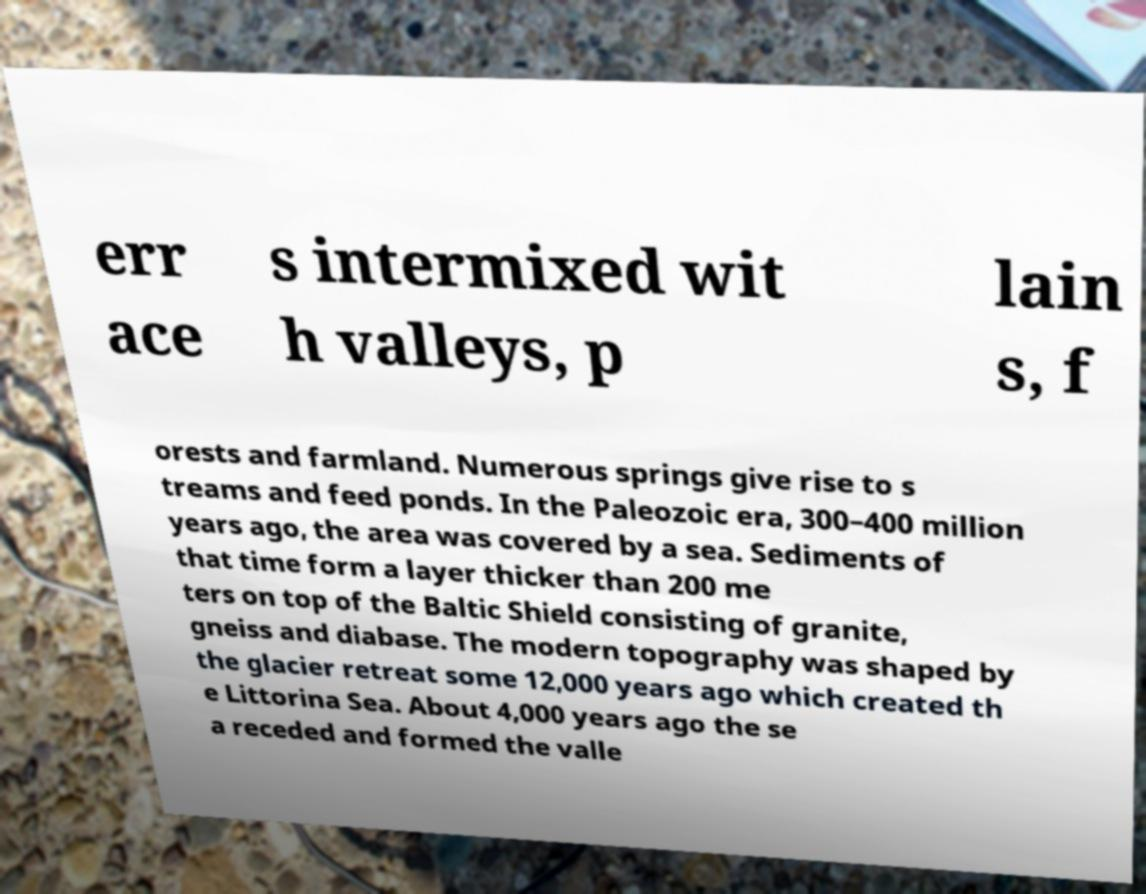Can you accurately transcribe the text from the provided image for me? err ace s intermixed wit h valleys, p lain s, f orests and farmland. Numerous springs give rise to s treams and feed ponds. In the Paleozoic era, 300–400 million years ago, the area was covered by a sea. Sediments of that time form a layer thicker than 200 me ters on top of the Baltic Shield consisting of granite, gneiss and diabase. The modern topography was shaped by the glacier retreat some 12,000 years ago which created th e Littorina Sea. About 4,000 years ago the se a receded and formed the valle 